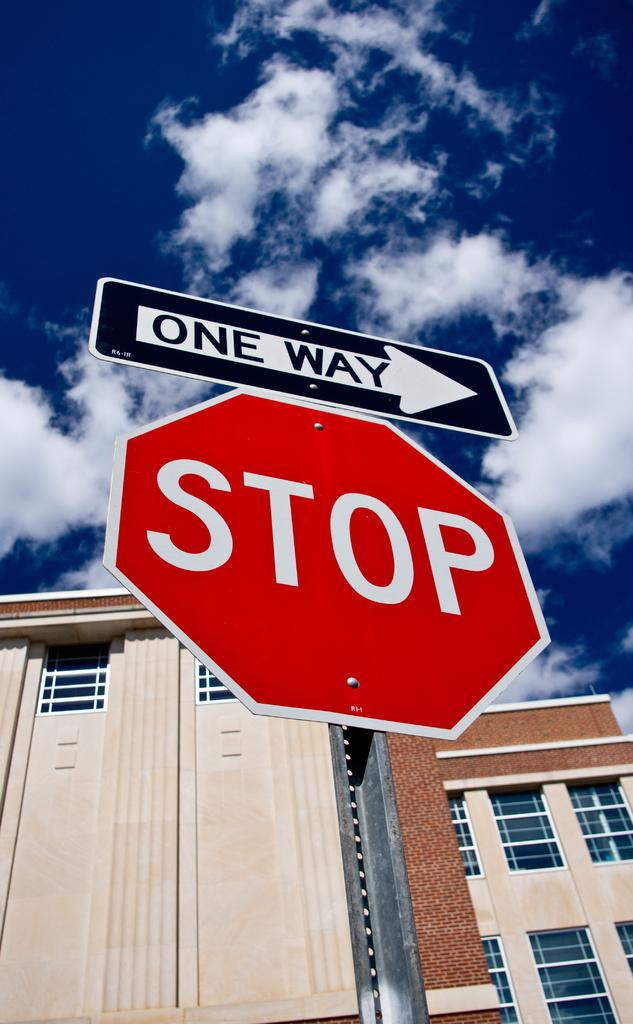What is the main object in the foreground of the image? There is a sign board in the image. What can be seen behind the sign board? There is a building behind the sign board. What is visible in the sky at the top of the image? Clouds are visible in the sky at the top of the image. Can you tell me how many geese are sitting on the stove in the image? There are no geese or stoves present in the image. What type of credit card is being advertised on the sign board? The image does not provide information about any credit card being advertised on the sign board. 